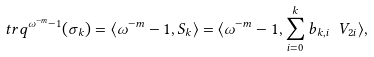<formula> <loc_0><loc_0><loc_500><loc_500>\ t r q ^ { \omega ^ { - m } - 1 } ( \sigma _ { k } ) = \langle \omega ^ { - m } - 1 , S _ { k } \rangle = \langle \omega ^ { - m } - 1 , \sum _ { i = 0 } ^ { k } b _ { k , i } \ V _ { 2 i } \rangle ,</formula> 